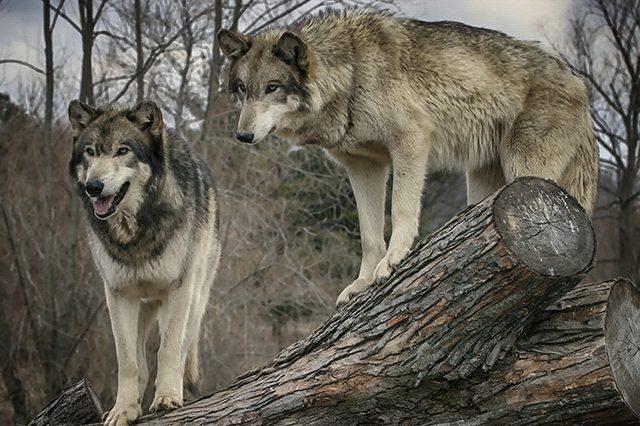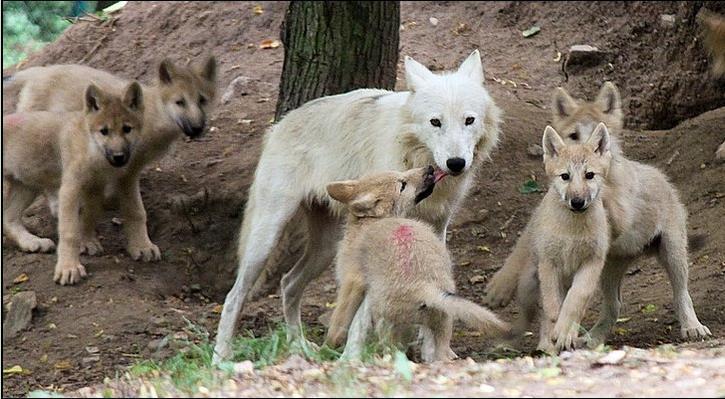The first image is the image on the left, the second image is the image on the right. Given the left and right images, does the statement "One image shows at least two forward-facing wolf pups standing side-by-side and no adult wolves, and the other image shows an adult wolf and pups, with its muzzle touching one pup." hold true? Answer yes or no. No. The first image is the image on the left, the second image is the image on the right. Analyze the images presented: Is the assertion "There is no more than three wolves in the right image." valid? Answer yes or no. No. 